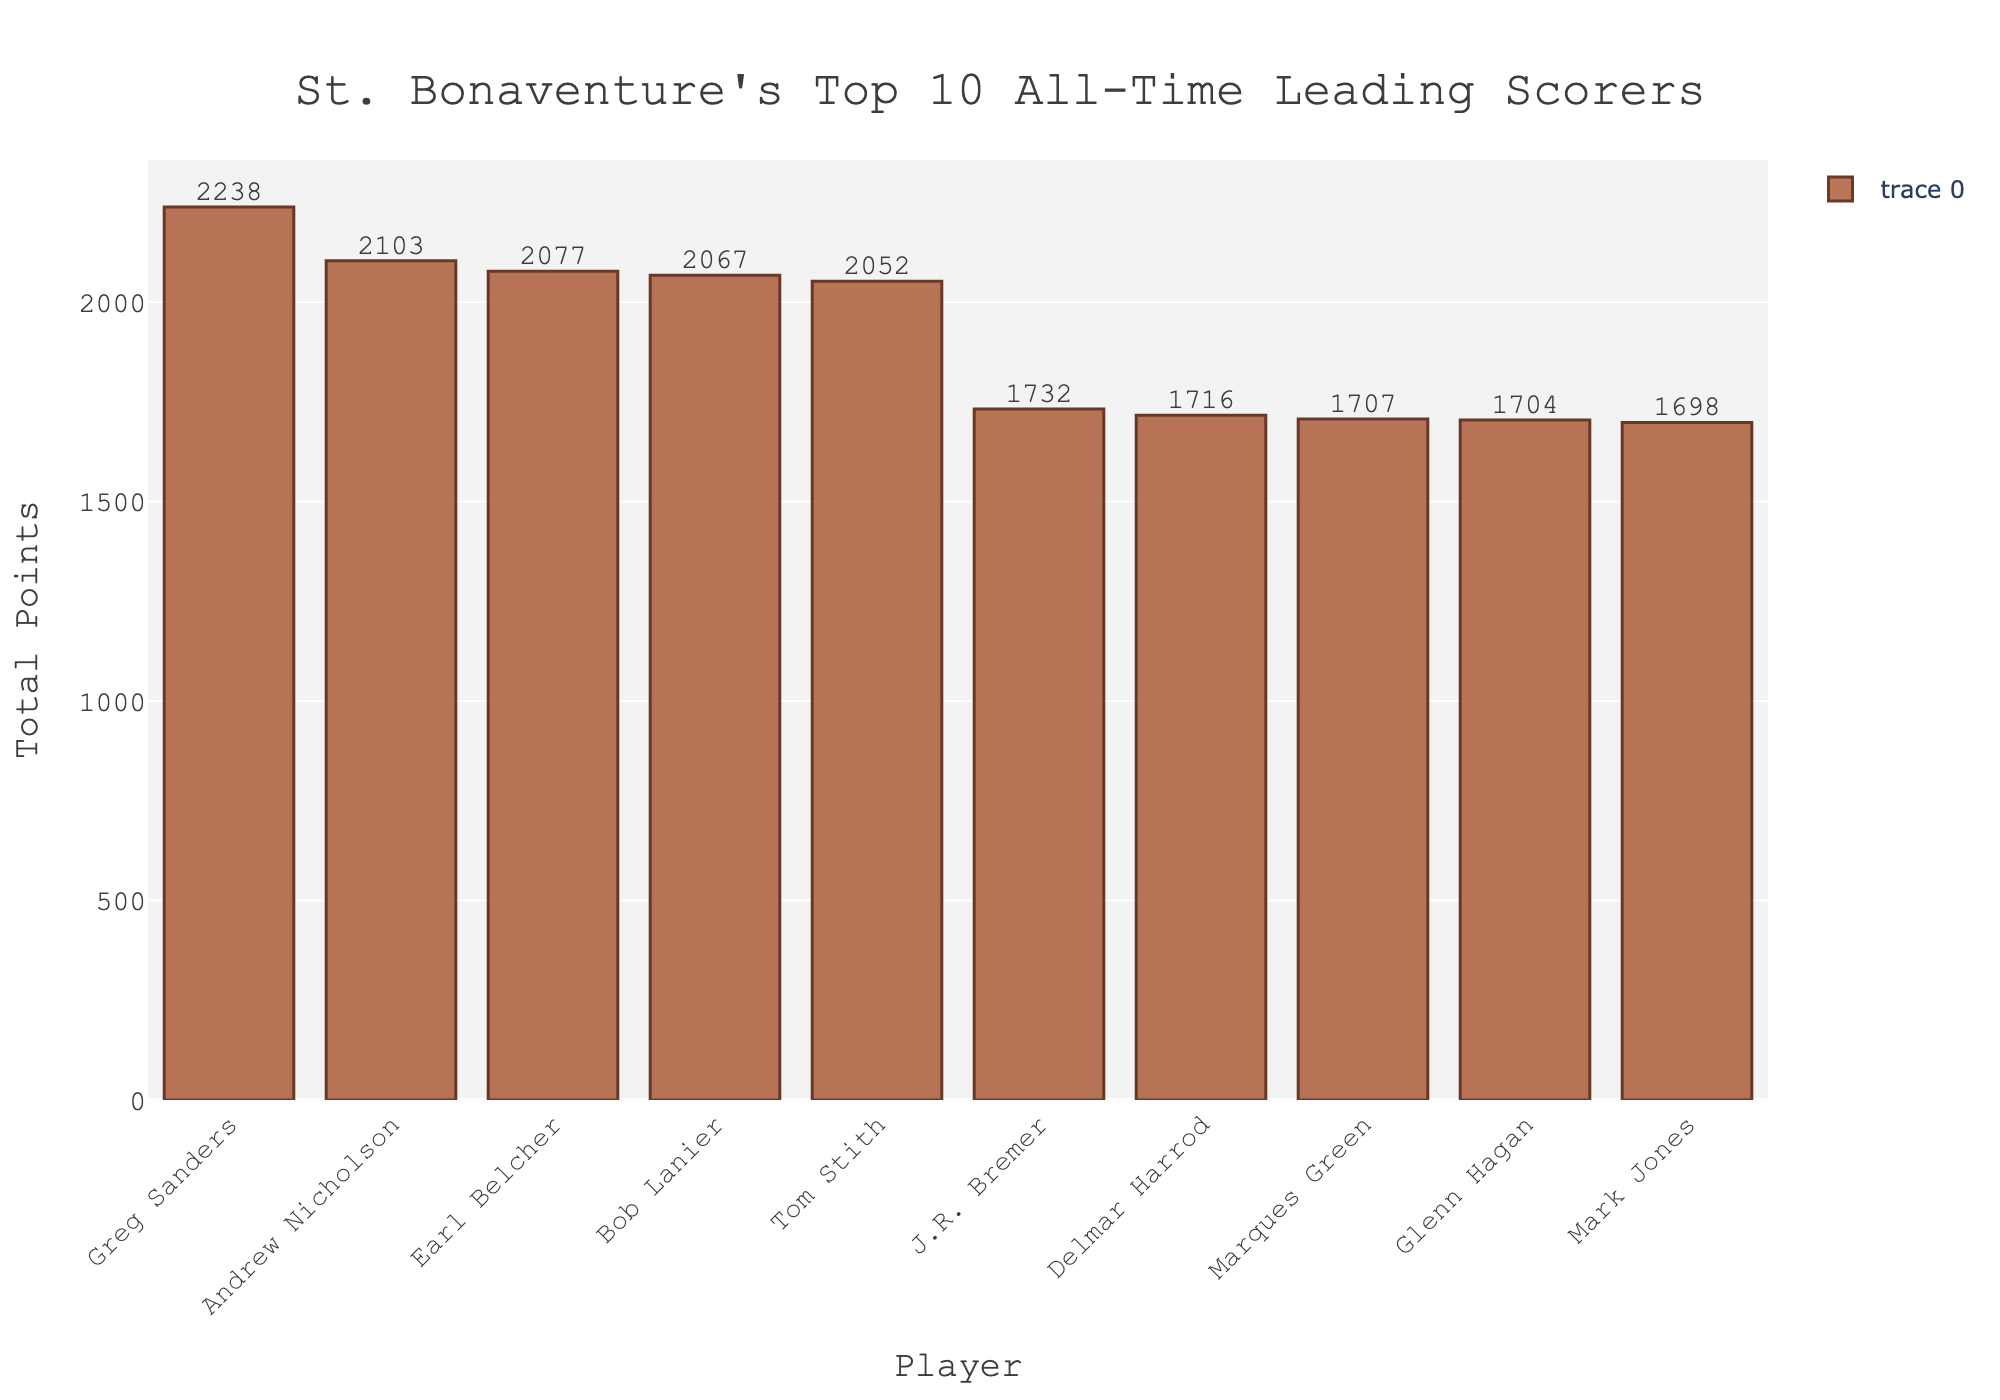How many points separate the top scorer from the second highest scorer? The top scorer is Greg Sanders with 2238 points, and the second highest scorer is Andrew Nicholson with 2103 points. The difference is 2238 - 2103 = 135 points.
Answer: 135 Who is the fourth highest scorer and how many points did they score? To find the fourth highest scorer, we look at the sorted bar chart. Earl Belcher is the fourth highest scorer with 2077 points.
Answer: Earl Belcher, 2077 What is the total number of points scored by the top five players combined? Sum the points of the top five players: 2238 (Greg Sanders) + 2103 (Andrew Nicholson) + 2077 (Earl Belcher) + 2067 (Bob Lanier) + 2052 (Tom Stith) = 10537 points.
Answer: 10537 Compare the total points of the player with the least points (Mark Jones) to the player with the most points (Greg Sanders). How much less did Mark Jones score? Mark Jones scored 1698 points, and Greg Sanders scored 2238 points. The difference is 2238 - 1698 = 540 points.
Answer: 540 Which player scored just over 1700 points and is ranked lower than Delmar Harrod? Marques Green scored 1707 points, which is just over 1700, and is ranked below Delmar Harrod who scored 1716 points.
Answer: Marques Green What is the average number of points scored by the top 3 scorers? The top three scorers are Greg Sanders (2238), Andrew Nicholson (2103), and Earl Belcher (2077). The average is (2238 + 2103 + 2077) / 3 = 2139.33 (rounded to two decimal places).
Answer: 2139.33 Who is the player with the third fewest points and how many points did they score? The player with the third fewest points is Marques Green, who scored 1707 points.
Answer: Marques Green, 1707 How many players scored between 1600 and 1800 points? By looking at the bar chart, there are five players: J.R. Bremer (1732), Delmar Harrod (1716), Marques Green (1707), Glenn Hagan (1704), and Mark Jones (1698), indicating they all scored between 1600 and 1800 points.
Answer: 5 Is the difference in points between Glenn Hagan and Mark Jones greater than 10? Glenn Hagan scored 1704 points, and Mark Jones scored 1698 points. The difference is 1704 - 1698 = 6 points, which is not greater than 10.
Answer: No 